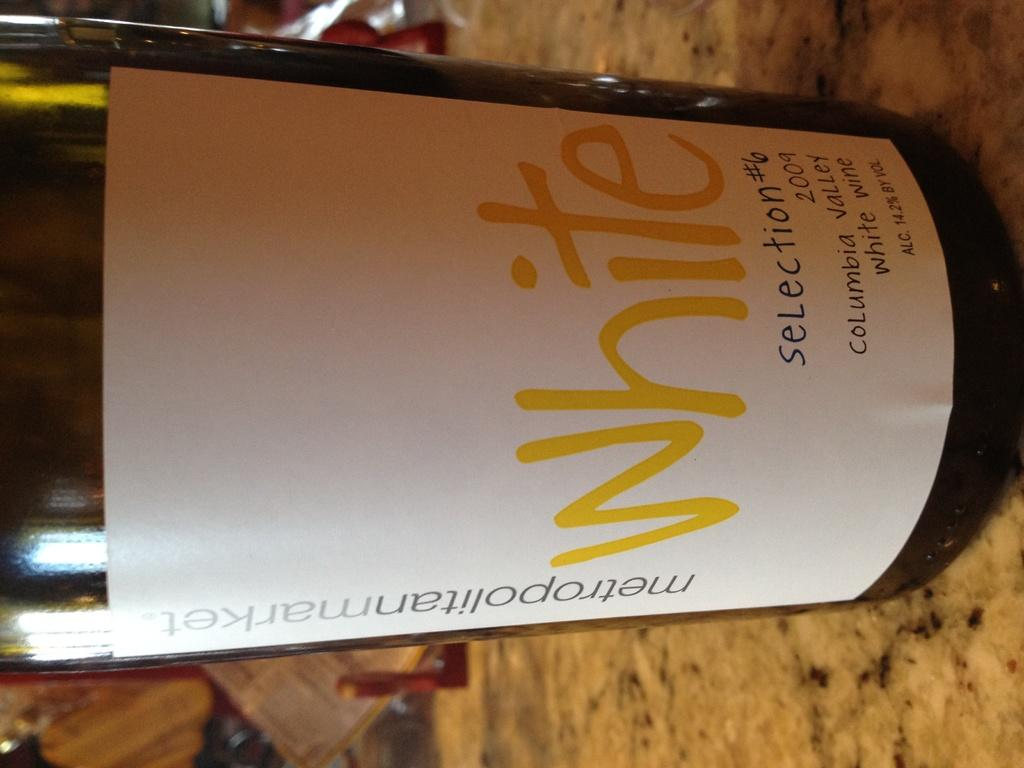Provide a one-sentence caption for the provided image. A bottle of white wine from metropolitanmarket on a granite table. 